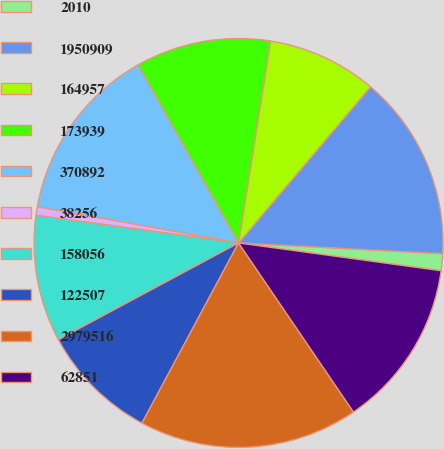Convert chart. <chart><loc_0><loc_0><loc_500><loc_500><pie_chart><fcel>2010<fcel>1950909<fcel>164957<fcel>173939<fcel>370892<fcel>38256<fcel>158056<fcel>122507<fcel>2979516<fcel>62851<nl><fcel>1.33%<fcel>14.67%<fcel>8.67%<fcel>10.67%<fcel>14.0%<fcel>0.67%<fcel>10.0%<fcel>9.33%<fcel>17.33%<fcel>13.33%<nl></chart> 